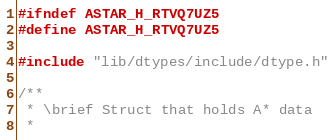Convert code to text. <code><loc_0><loc_0><loc_500><loc_500><_C_>#ifndef ASTAR_H_RTVQ7UZ5
#define ASTAR_H_RTVQ7UZ5

#include "lib/dtypes/include/dtype.h"

/**
 * \brief Struct that holds A* data
 *</code> 